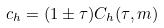<formula> <loc_0><loc_0><loc_500><loc_500>c _ { h } = ( 1 \pm \tau ) C _ { h } ( \tau , m )</formula> 